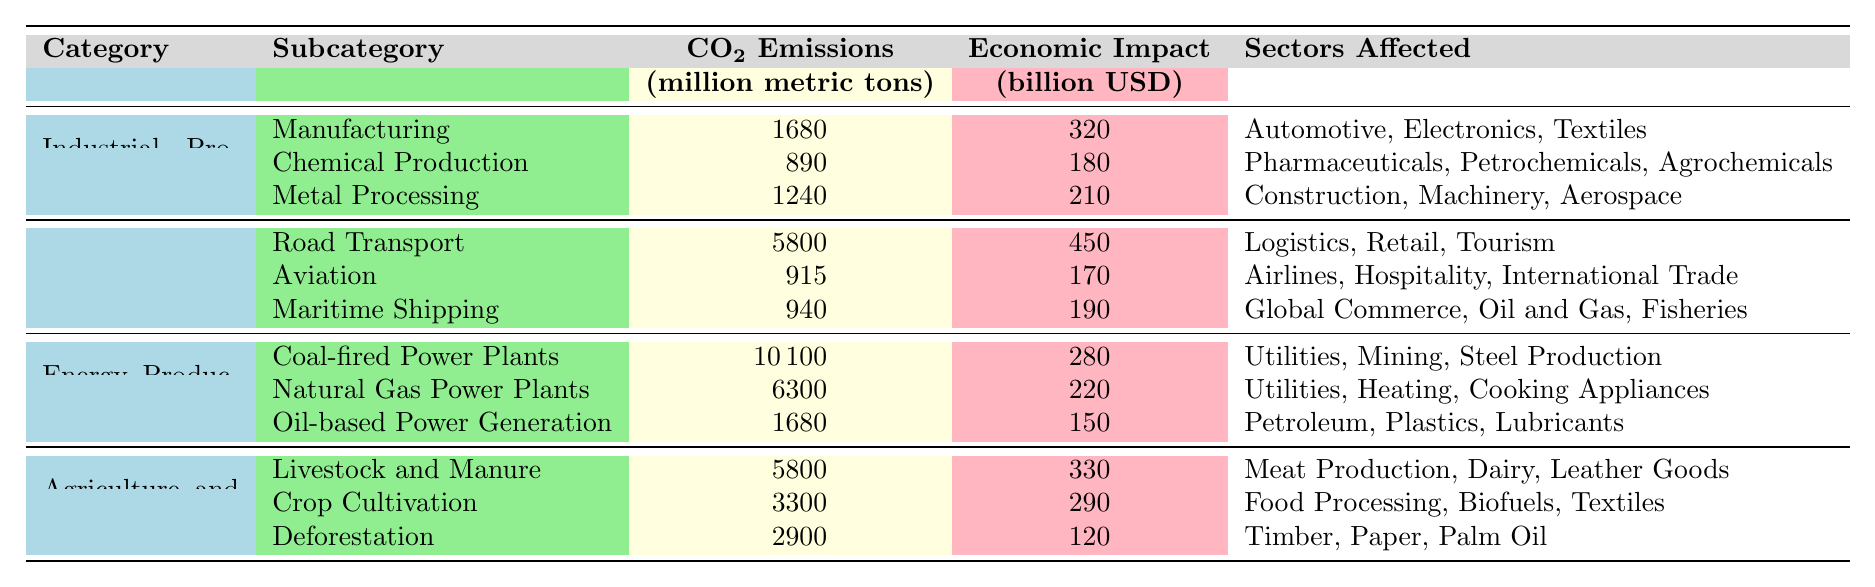What is the total CO2 emissions from the Industrial Processes category? For the Industrial Processes category, the CO2 emissions are: Manufacturing (1680), Chemical Production (890), and Metal Processing (1240). Adding these values gives: 1680 + 890 + 1240 = 3810 million metric tons.
Answer: 3810 million metric tons What is the economic impact of the Transportation category? The economic impacts for the Transportation category are: Road Transport (450), Aviation (170), and Maritime Shipping (190). Adding these values gives: 450 + 170 + 190 = 810 billion USD.
Answer: 810 billion USD Which subcategory has the highest CO2 emissions? The subcategory with the highest CO2 emissions is Coal-fired Power Plants with 10100 million metric tons.
Answer: Coal-fired Power Plants How many sectors are affected by Metal Processing? The Metal Processing subcategory lists three affected sectors: Construction, Machinery, and Aerospace.
Answer: 3 sectors What is the economic impact of Deforestation? The economic impact of Deforestation is 120 billion USD according to the table.
Answer: 120 billion USD Which transportation subcategory has the lowest economic impact? The Aviation subcategory shows an economic impact of 170 billion USD, which is lower than the other two transportation subcategories (Road Transport and Maritime Shipping) with 450 and 190 billion USD, respectively.
Answer: Aviation What are the total CO2 emissions from Energy Production? The Energy Production category consists of Coal-fired Power Plants (10100), Natural Gas Power Plants (6300), and Oil-based Power Generation (1680). Adding these values gives: 10100 + 6300 + 1680 = 18180 million metric tons.
Answer: 18180 million metric tons Is the economic impact of the Agriculture and Land Use category greater than that of the Energy Production category? The economic impact of Agriculture and Land Use is calculated as: Livestock and Manure (330) + Crop Cultivation (290) + Deforestation (120) = 740 billion USD. The economic impact from Energy Production is 280 + 220 + 150 = 650 billion USD. Since 740 > 650, the statement is true.
Answer: Yes What is the difference in total CO2 emissions between the Transportation and Agriculture and Land Use categories? The total CO2 emissions for Transportation are: Road Transport (5800) + Aviation (915) + Maritime Shipping (940) = 7655 million metric tons. For Agriculture and Land Use: Livestock and Manure (5800) + Crop Cultivation (3300) + Deforestation (2900) = 12000 million metric tons. The difference is 12000 - 7655 = 4345 million metric tons.
Answer: 4345 million metric tons Which category has the largest total economic impact, and what is its value? The total economic impacts are: Industrial Processes (320), Transportation (810), Energy Production (650), Agriculture and Land Use (740). The largest is Transportation with an economic impact of 810 billion USD.
Answer: Transportation, 810 billion USD 